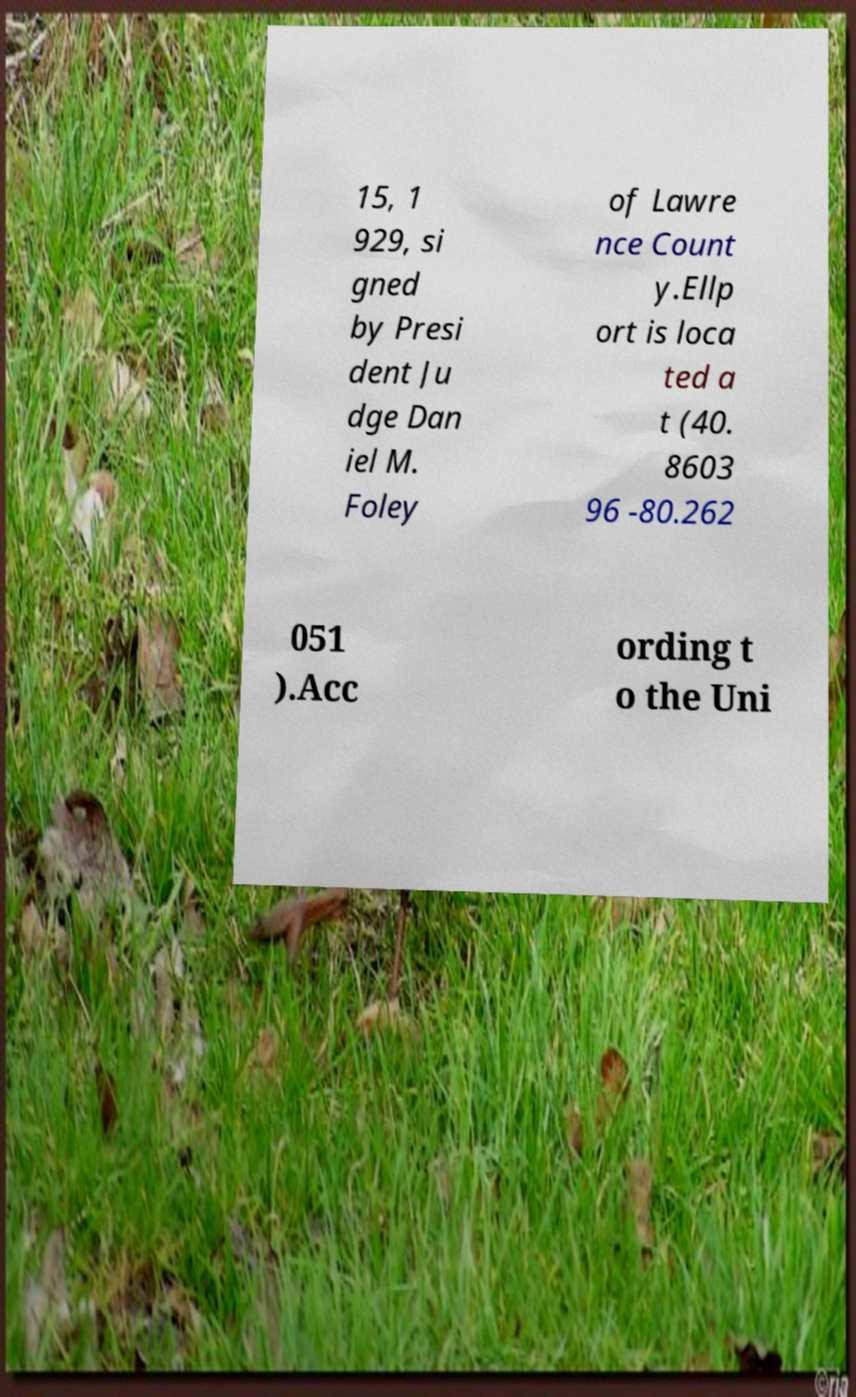Could you assist in decoding the text presented in this image and type it out clearly? 15, 1 929, si gned by Presi dent Ju dge Dan iel M. Foley of Lawre nce Count y.Ellp ort is loca ted a t (40. 8603 96 -80.262 051 ).Acc ording t o the Uni 